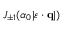Convert formula to latex. <formula><loc_0><loc_0><loc_500><loc_500>J _ { \pm 1 } ( \alpha _ { 0 } | \varepsilon \cdot { q } | )</formula> 